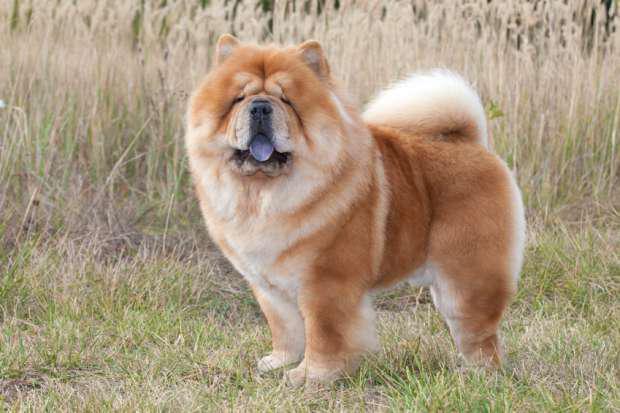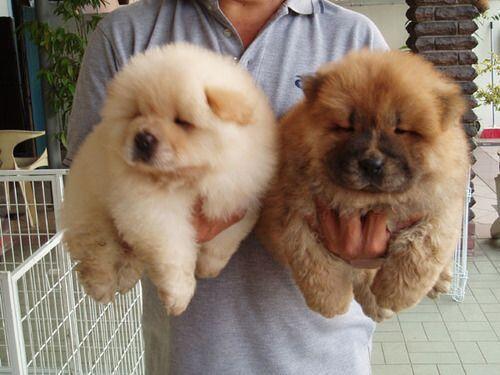The first image is the image on the left, the second image is the image on the right. For the images shown, is this caption "There is a human handling at least one dog in the right image." true? Answer yes or no. Yes. The first image is the image on the left, the second image is the image on the right. For the images shown, is this caption "A human is holding at least one Chow Chow puppy in their arms." true? Answer yes or no. Yes. 